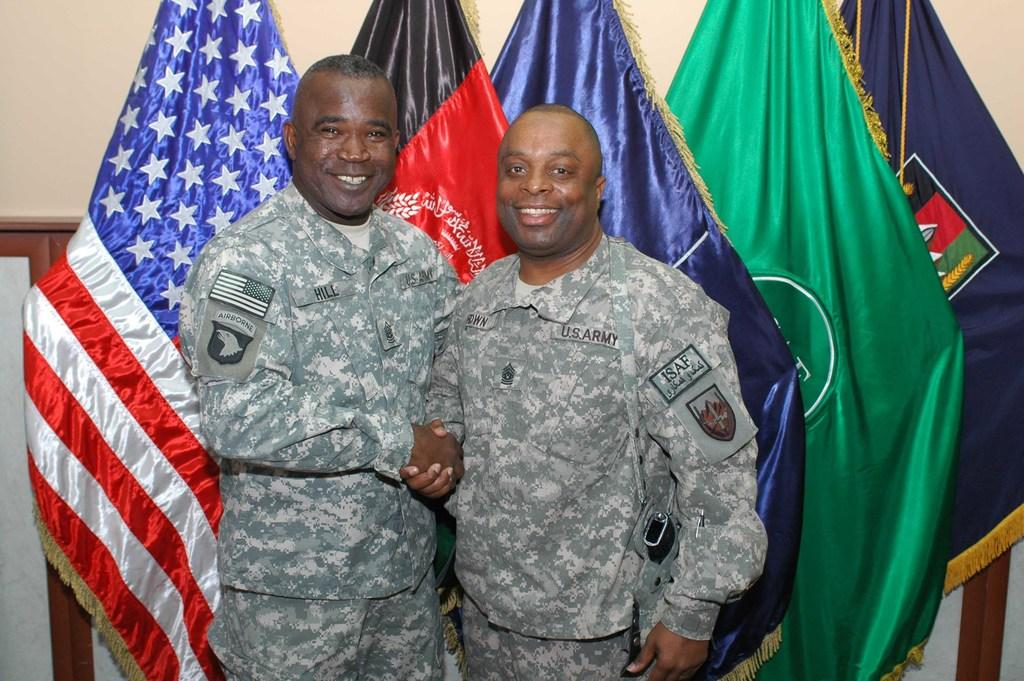What are the persons in the image doing? The persons in the image are standing in the center and shaking hands with each other. What is the facial expression of the persons in the image? The persons are smiling in the image. What can be seen in the background of the image? There are flags and a wall in the background of the image. What type of teeth can be seen in the image? There are no teeth visible in the image, as it features persons shaking hands and smiling, but not showing their teeth. 